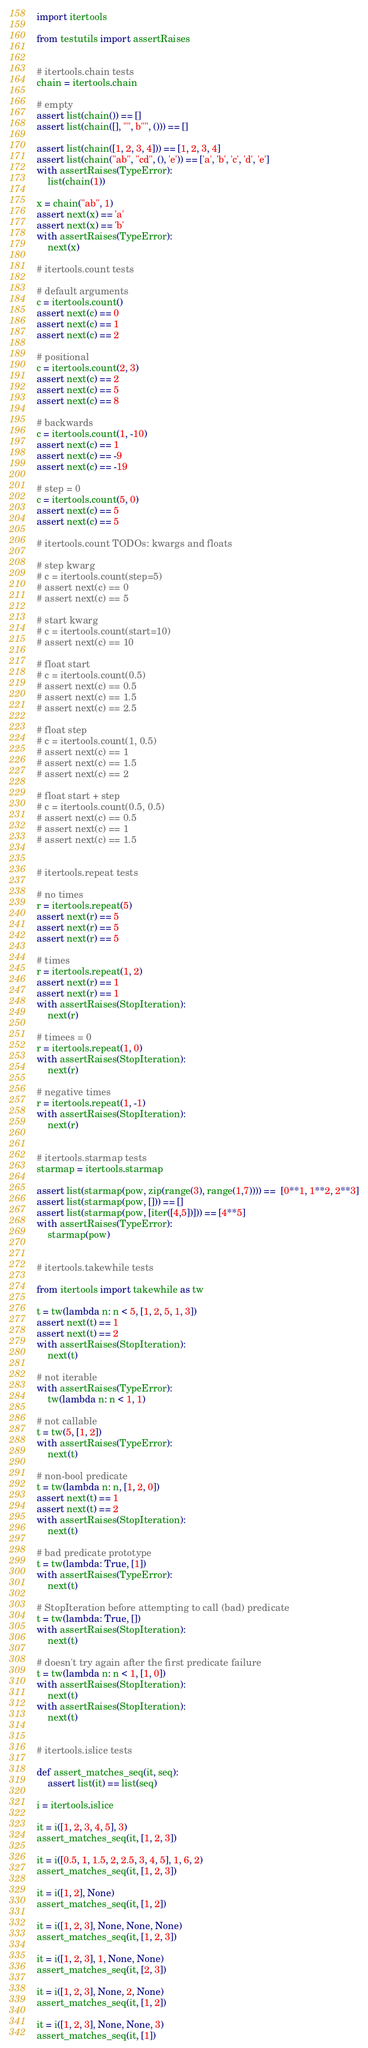<code> <loc_0><loc_0><loc_500><loc_500><_Python_>import itertools

from testutils import assertRaises


# itertools.chain tests
chain = itertools.chain

# empty
assert list(chain()) == []
assert list(chain([], "", b"", ())) == []

assert list(chain([1, 2, 3, 4])) == [1, 2, 3, 4]
assert list(chain("ab", "cd", (), 'e')) == ['a', 'b', 'c', 'd', 'e']
with assertRaises(TypeError):
    list(chain(1))

x = chain("ab", 1)
assert next(x) == 'a'
assert next(x) == 'b'
with assertRaises(TypeError):
    next(x)

# itertools.count tests

# default arguments
c = itertools.count()
assert next(c) == 0
assert next(c) == 1
assert next(c) == 2

# positional
c = itertools.count(2, 3)
assert next(c) == 2
assert next(c) == 5
assert next(c) == 8

# backwards
c = itertools.count(1, -10)
assert next(c) == 1
assert next(c) == -9
assert next(c) == -19

# step = 0
c = itertools.count(5, 0)
assert next(c) == 5
assert next(c) == 5

# itertools.count TODOs: kwargs and floats

# step kwarg
# c = itertools.count(step=5)
# assert next(c) == 0
# assert next(c) == 5

# start kwarg
# c = itertools.count(start=10)
# assert next(c) == 10

# float start
# c = itertools.count(0.5)
# assert next(c) == 0.5
# assert next(c) == 1.5
# assert next(c) == 2.5

# float step
# c = itertools.count(1, 0.5)
# assert next(c) == 1
# assert next(c) == 1.5
# assert next(c) == 2

# float start + step
# c = itertools.count(0.5, 0.5)
# assert next(c) == 0.5
# assert next(c) == 1
# assert next(c) == 1.5


# itertools.repeat tests

# no times
r = itertools.repeat(5)
assert next(r) == 5
assert next(r) == 5
assert next(r) == 5

# times
r = itertools.repeat(1, 2)
assert next(r) == 1
assert next(r) == 1
with assertRaises(StopIteration):
    next(r)

# timees = 0
r = itertools.repeat(1, 0)
with assertRaises(StopIteration):
    next(r)

# negative times
r = itertools.repeat(1, -1)
with assertRaises(StopIteration):
    next(r)


# itertools.starmap tests
starmap = itertools.starmap

assert list(starmap(pow, zip(range(3), range(1,7)))) ==  [0**1, 1**2, 2**3]
assert list(starmap(pow, [])) == []
assert list(starmap(pow, [iter([4,5])])) == [4**5]
with assertRaises(TypeError):
    starmap(pow)


# itertools.takewhile tests

from itertools import takewhile as tw

t = tw(lambda n: n < 5, [1, 2, 5, 1, 3])
assert next(t) == 1
assert next(t) == 2
with assertRaises(StopIteration):
    next(t)

# not iterable
with assertRaises(TypeError):
    tw(lambda n: n < 1, 1)

# not callable
t = tw(5, [1, 2])
with assertRaises(TypeError):
    next(t)

# non-bool predicate
t = tw(lambda n: n, [1, 2, 0])
assert next(t) == 1
assert next(t) == 2
with assertRaises(StopIteration):
    next(t)

# bad predicate prototype
t = tw(lambda: True, [1])
with assertRaises(TypeError):
    next(t)

# StopIteration before attempting to call (bad) predicate
t = tw(lambda: True, [])
with assertRaises(StopIteration):
    next(t)

# doesn't try again after the first predicate failure
t = tw(lambda n: n < 1, [1, 0])
with assertRaises(StopIteration):
    next(t)
with assertRaises(StopIteration):
    next(t)


# itertools.islice tests

def assert_matches_seq(it, seq):
    assert list(it) == list(seq)

i = itertools.islice

it = i([1, 2, 3, 4, 5], 3)
assert_matches_seq(it, [1, 2, 3])

it = i([0.5, 1, 1.5, 2, 2.5, 3, 4, 5], 1, 6, 2)
assert_matches_seq(it, [1, 2, 3])

it = i([1, 2], None)
assert_matches_seq(it, [1, 2])

it = i([1, 2, 3], None, None, None)
assert_matches_seq(it, [1, 2, 3])

it = i([1, 2, 3], 1, None, None)
assert_matches_seq(it, [2, 3])

it = i([1, 2, 3], None, 2, None)
assert_matches_seq(it, [1, 2])

it = i([1, 2, 3], None, None, 3)
assert_matches_seq(it, [1])
</code> 